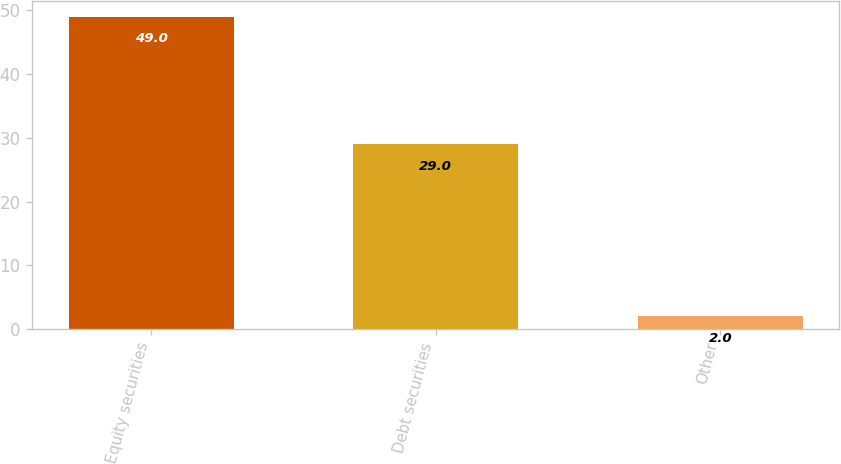Convert chart. <chart><loc_0><loc_0><loc_500><loc_500><bar_chart><fcel>Equity securities<fcel>Debt securities<fcel>Other<nl><fcel>49<fcel>29<fcel>2<nl></chart> 